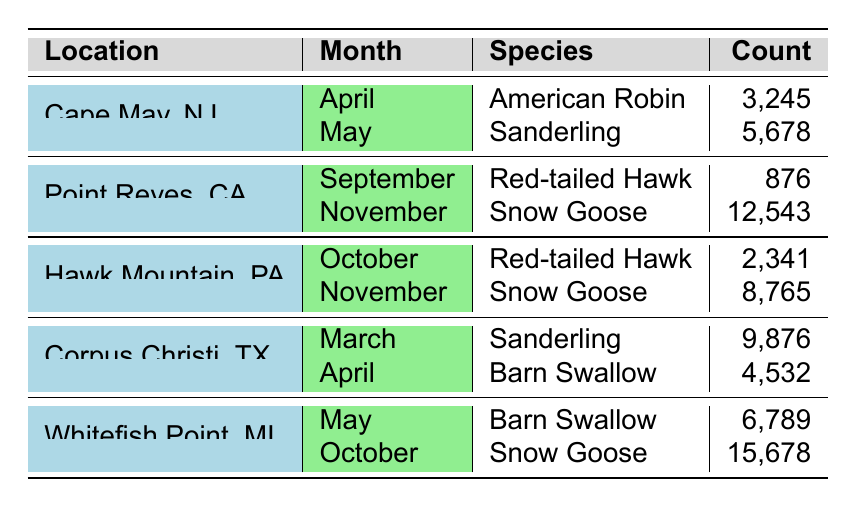What is the bird species observed at Cape May, NJ in April? By referring to the table, we find that the location Cape May, NJ has the entry for April with the species American Robin.
Answer: American Robin Which month has the highest count of Snow Goose in the data? We can check the counts for Snow Goose across all locations and months. The highest count is 15,678 observed in October at Whitefish Point, MI.
Answer: October How many Sanderlings were counted in Corpus Christi, TX? The table shows that there were 9,876 Sanderlings counted in Corpus Christi, TX during the month of March.
Answer: 9,876 What is the total count of Red-tailed Hawks observed across all locations and months? Adding the counts of Red-tailed Hawks: 876 (Point Reyes, September) + 2,341 (Hawk Mountain, October) = 3,217.
Answer: 3,217 Did Cape May, NJ have more American Robins or Sanderlings? The count for American Robins in April is 3,245, while the Sanderlings in May is 5,678. Therefore, Cape May, NJ had more Sanderlings.
Answer: Yes Which location had the highest count of birds in any month? Checking all entries, the highest count is 15,678 for Snow Goose in October at Whitefish Point, MI.
Answer: Whitefish Point, MI What is the average count of Snow Geese observed across all months? The counts for Snow Goose are 12,543 (Point Reyes, November) and 8,765 (Hawk Mountain, November), totaling 21,308. The average is 21,308 / 2 = 10,654.
Answer: 10,654 Is there any location where Barn Swallow was observed? Looking through the table, Barn Swallow is observed at Corpus Christi, TX in April (4,532) and at Whitefish Point, MI in May (6,789).
Answer: Yes How many more American Robins were counted at Cape May, NJ compared to Sanderlings at the same location? At Cape May, NJ, 3,245 American Robins were counted in April, while 5,678 Sanderlings were counted in May. The difference is 5,678 - 3,245 = 2,433, meaning there were more Sanderlings.
Answer: 2,433 Which location has the greatest diversity of species identified in the table? Each location has one or two species listed. Cape May, NJ has two different species, while others have either one or two. The data shows Cape May, NJ with American Robin and Sanderling, which makes it one of the locations with more diversity.
Answer: Cape May, NJ 